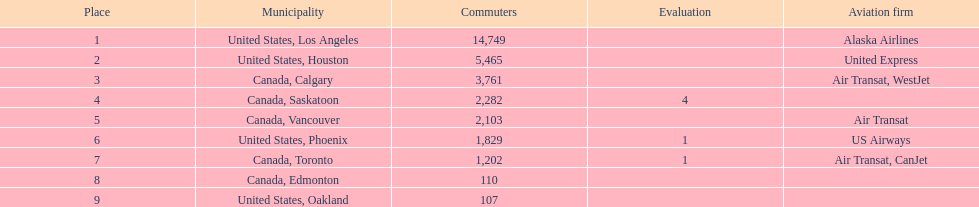The difference in passengers between los angeles and toronto 13,547. 